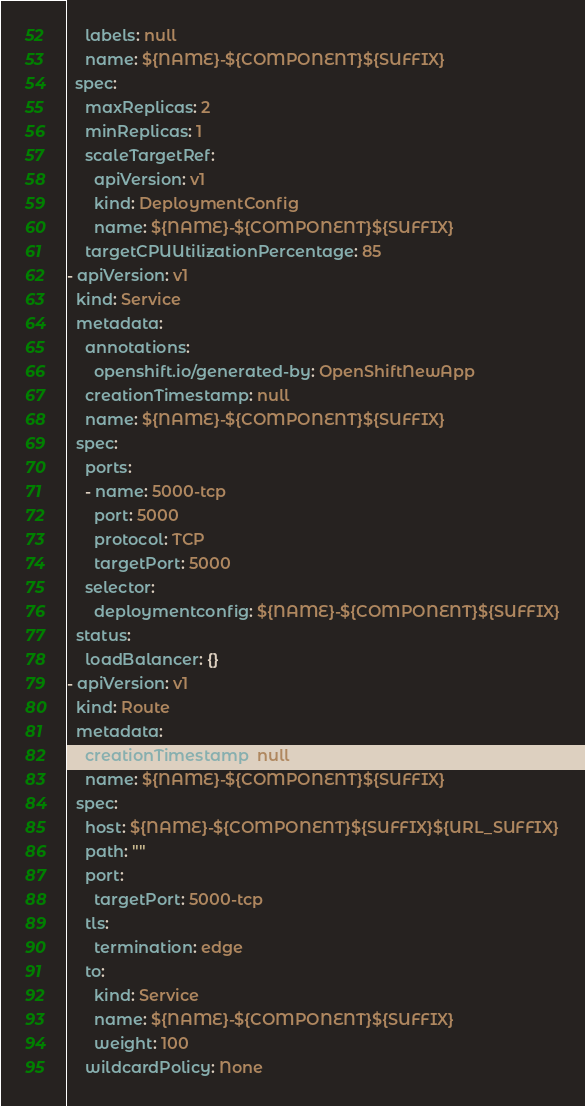<code> <loc_0><loc_0><loc_500><loc_500><_YAML_>    labels: null
    name: ${NAME}-${COMPONENT}${SUFFIX}
  spec:
    maxReplicas: 2
    minReplicas: 1
    scaleTargetRef:
      apiVersion: v1
      kind: DeploymentConfig
      name: ${NAME}-${COMPONENT}${SUFFIX}
    targetCPUUtilizationPercentage: 85
- apiVersion: v1
  kind: Service
  metadata:
    annotations:
      openshift.io/generated-by: OpenShiftNewApp
    creationTimestamp: null
    name: ${NAME}-${COMPONENT}${SUFFIX}
  spec:
    ports:
    - name: 5000-tcp
      port: 5000
      protocol: TCP
      targetPort: 5000
    selector:
      deploymentconfig: ${NAME}-${COMPONENT}${SUFFIX}
  status:
    loadBalancer: {}
- apiVersion: v1
  kind: Route
  metadata:
    creationTimestamp: null
    name: ${NAME}-${COMPONENT}${SUFFIX}
  spec:
    host: ${NAME}-${COMPONENT}${SUFFIX}${URL_SUFFIX}
    path: ""
    port:
      targetPort: 5000-tcp
    tls:
      termination: edge
    to:
      kind: Service
      name: ${NAME}-${COMPONENT}${SUFFIX}
      weight: 100
    wildcardPolicy: None
</code> 